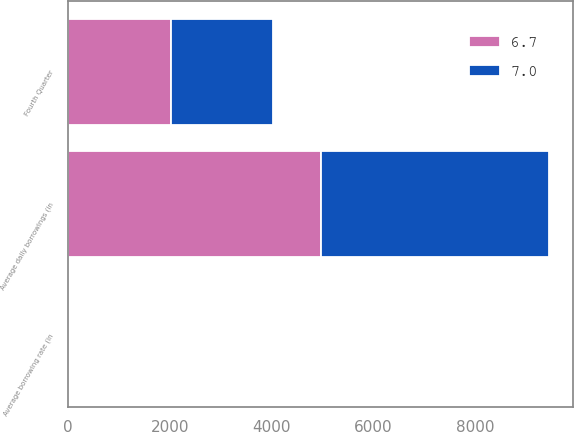Convert chart to OTSL. <chart><loc_0><loc_0><loc_500><loc_500><stacked_bar_chart><ecel><fcel>Fourth Quarter<fcel>Average daily borrowings (in<fcel>Average borrowing rate (in<nl><fcel>6.7<fcel>2013<fcel>4963<fcel>6.7<nl><fcel>7<fcel>2012<fcel>4484<fcel>7<nl></chart> 